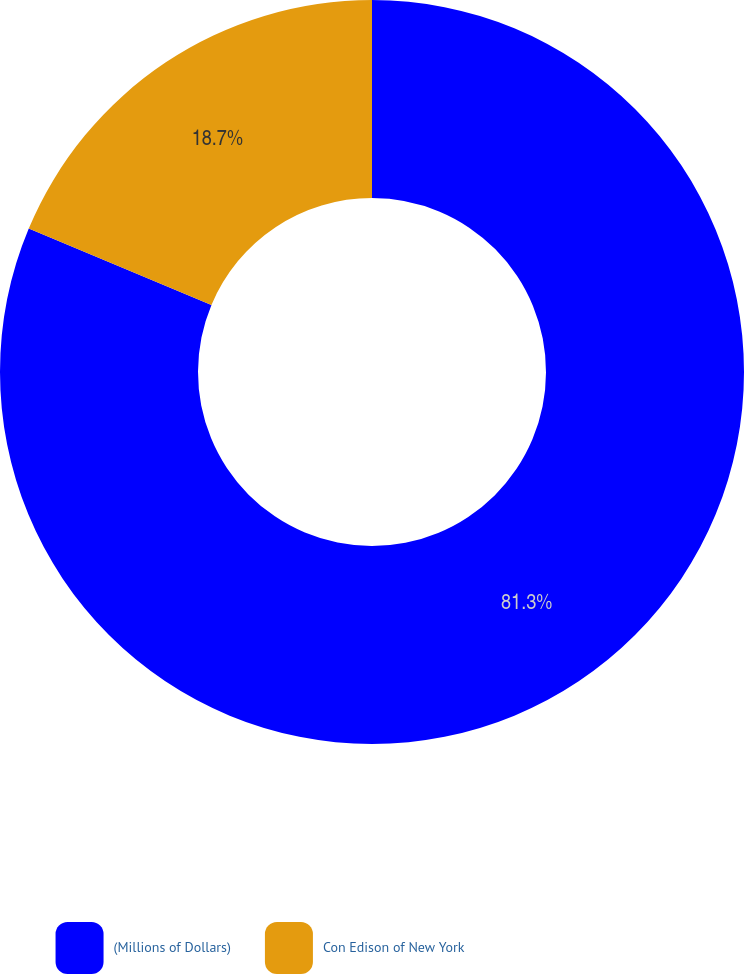<chart> <loc_0><loc_0><loc_500><loc_500><pie_chart><fcel>(Millions of Dollars)<fcel>Con Edison of New York<nl><fcel>81.3%<fcel>18.7%<nl></chart> 